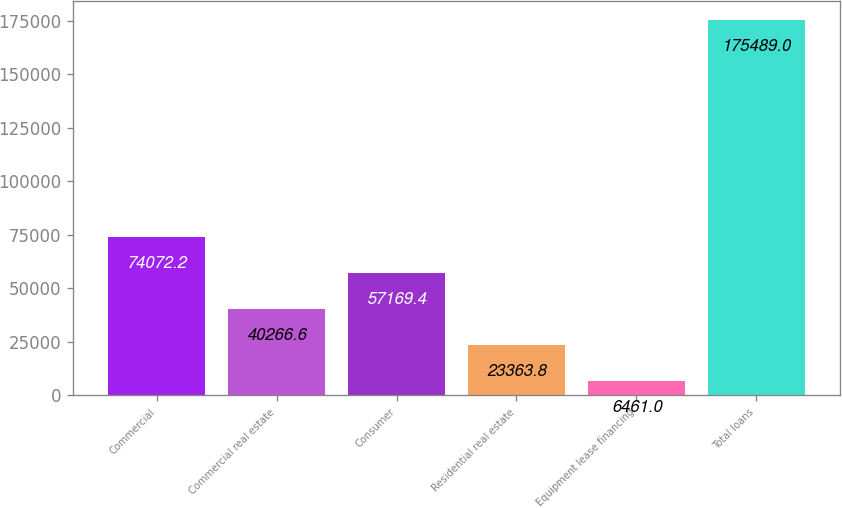<chart> <loc_0><loc_0><loc_500><loc_500><bar_chart><fcel>Commercial<fcel>Commercial real estate<fcel>Consumer<fcel>Residential real estate<fcel>Equipment lease financing<fcel>Total loans<nl><fcel>74072.2<fcel>40266.6<fcel>57169.4<fcel>23363.8<fcel>6461<fcel>175489<nl></chart> 